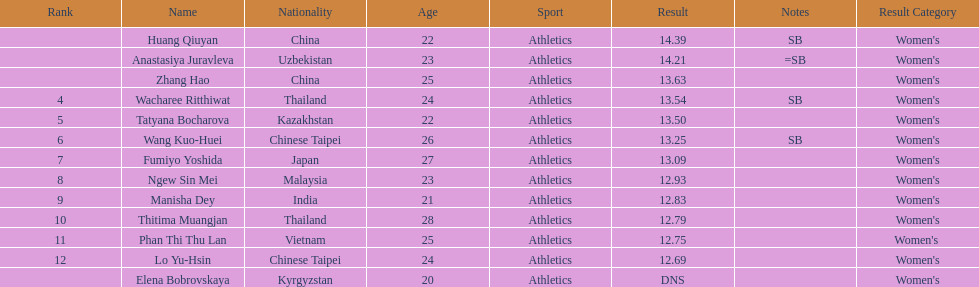Which country had the most competitors ranked in the top three in the event? China. Parse the full table. {'header': ['Rank', 'Name', 'Nationality', 'Age', 'Sport', 'Result', 'Notes', 'Result Category'], 'rows': [['', 'Huang Qiuyan', 'China', '22', 'Athletics', '14.39', 'SB', "Women's"], ['', 'Anastasiya Juravleva', 'Uzbekistan', '23', 'Athletics', '14.21', '=SB', "Women's"], ['', 'Zhang Hao', 'China', '25', 'Athletics', '13.63', '', "Women's"], ['4', 'Wacharee Ritthiwat', 'Thailand', '24', 'Athletics', '13.54', 'SB', "Women's"], ['5', 'Tatyana Bocharova', 'Kazakhstan', '22', 'Athletics', '13.50', '', "Women's"], ['6', 'Wang Kuo-Huei', 'Chinese Taipei', '26', 'Athletics', '13.25', 'SB', "Women's"], ['7', 'Fumiyo Yoshida', 'Japan', '27', 'Athletics', '13.09', '', "Women's"], ['8', 'Ngew Sin Mei', 'Malaysia', '23', 'Athletics', '12.93', '', "Women's"], ['9', 'Manisha Dey', 'India', '21', 'Athletics', '12.83', '', "Women's"], ['10', 'Thitima Muangjan', 'Thailand', '28', 'Athletics', '12.79', '', "Women's"], ['11', 'Phan Thi Thu Lan', 'Vietnam', '25', 'Athletics', '12.75', '', "Women's "], ['12', 'Lo Yu-Hsin', 'Chinese Taipei', '24', 'Athletics', '12.69', '', "Women's"], ['', 'Elena Bobrovskaya', 'Kyrgyzstan', '20', 'Athletics', 'DNS', '', "Women's"]]} 